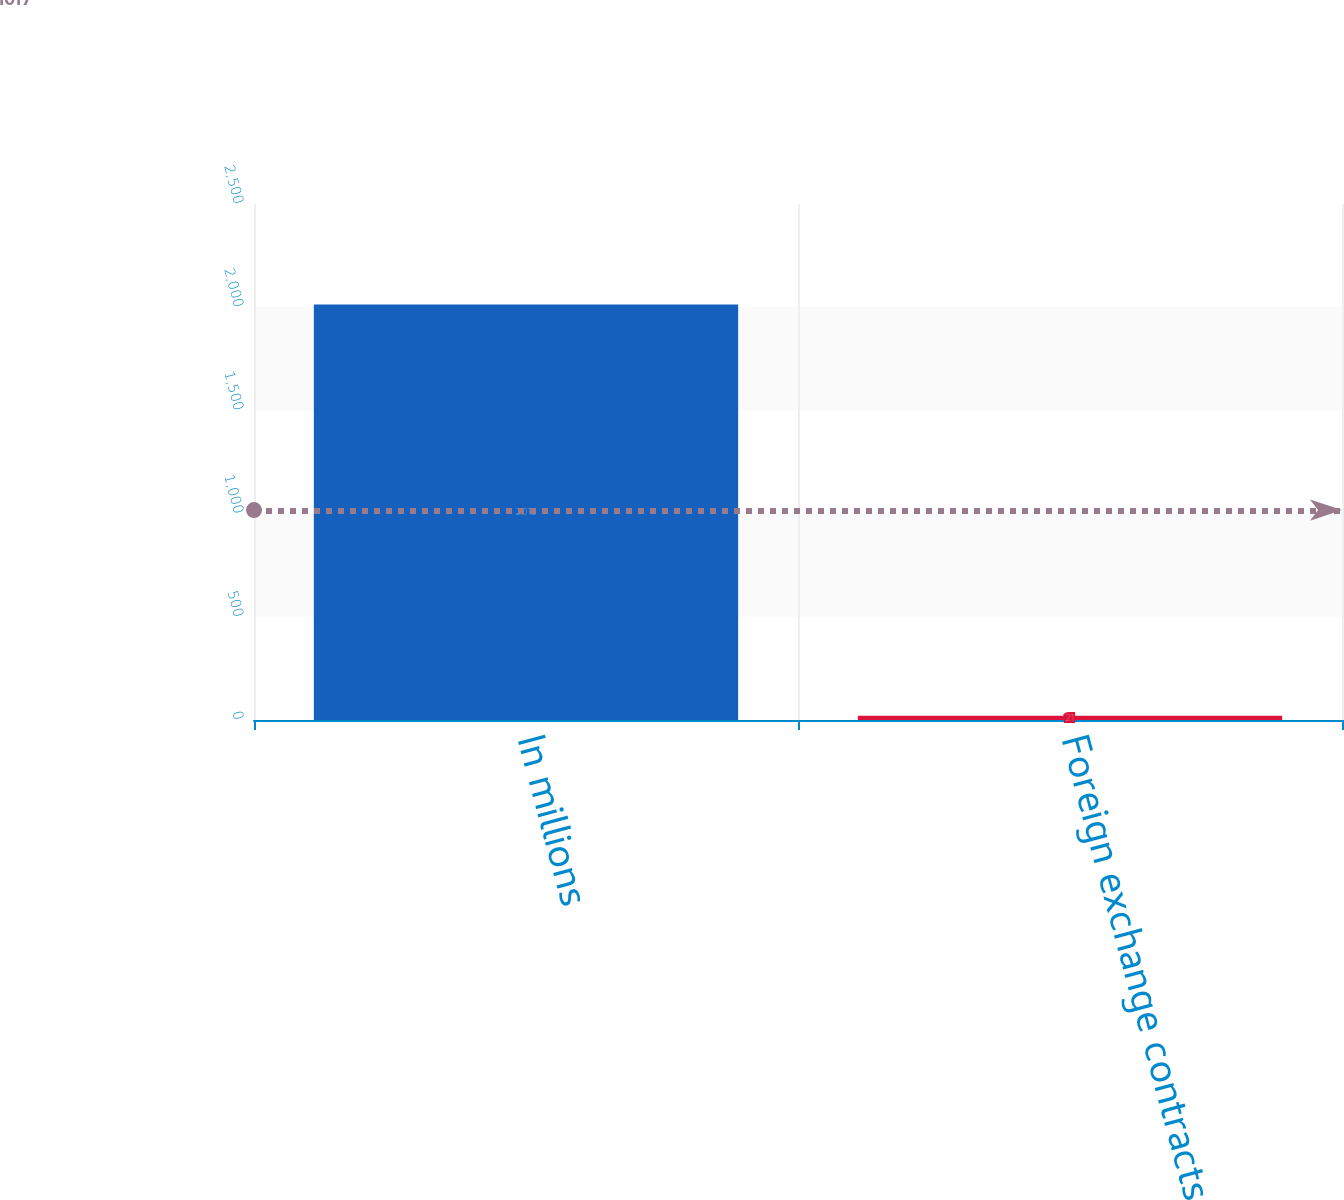Convert chart to OTSL. <chart><loc_0><loc_0><loc_500><loc_500><bar_chart><fcel>In millions<fcel>Foreign exchange contracts<nl><fcel>2013<fcel>21<nl></chart> 